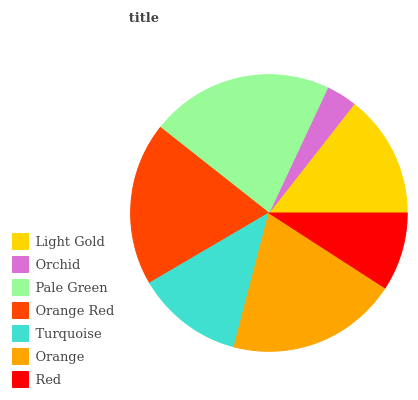Is Orchid the minimum?
Answer yes or no. Yes. Is Pale Green the maximum?
Answer yes or no. Yes. Is Pale Green the minimum?
Answer yes or no. No. Is Orchid the maximum?
Answer yes or no. No. Is Pale Green greater than Orchid?
Answer yes or no. Yes. Is Orchid less than Pale Green?
Answer yes or no. Yes. Is Orchid greater than Pale Green?
Answer yes or no. No. Is Pale Green less than Orchid?
Answer yes or no. No. Is Light Gold the high median?
Answer yes or no. Yes. Is Light Gold the low median?
Answer yes or no. Yes. Is Turquoise the high median?
Answer yes or no. No. Is Turquoise the low median?
Answer yes or no. No. 